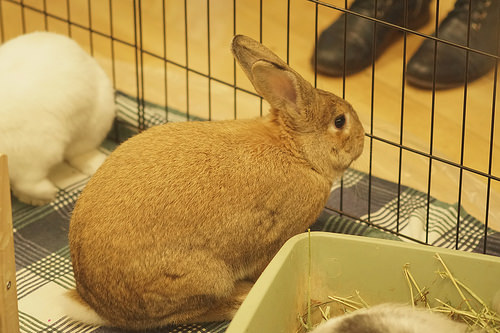<image>
Can you confirm if the shoe is in front of the bunny? Yes. The shoe is positioned in front of the bunny, appearing closer to the camera viewpoint. 